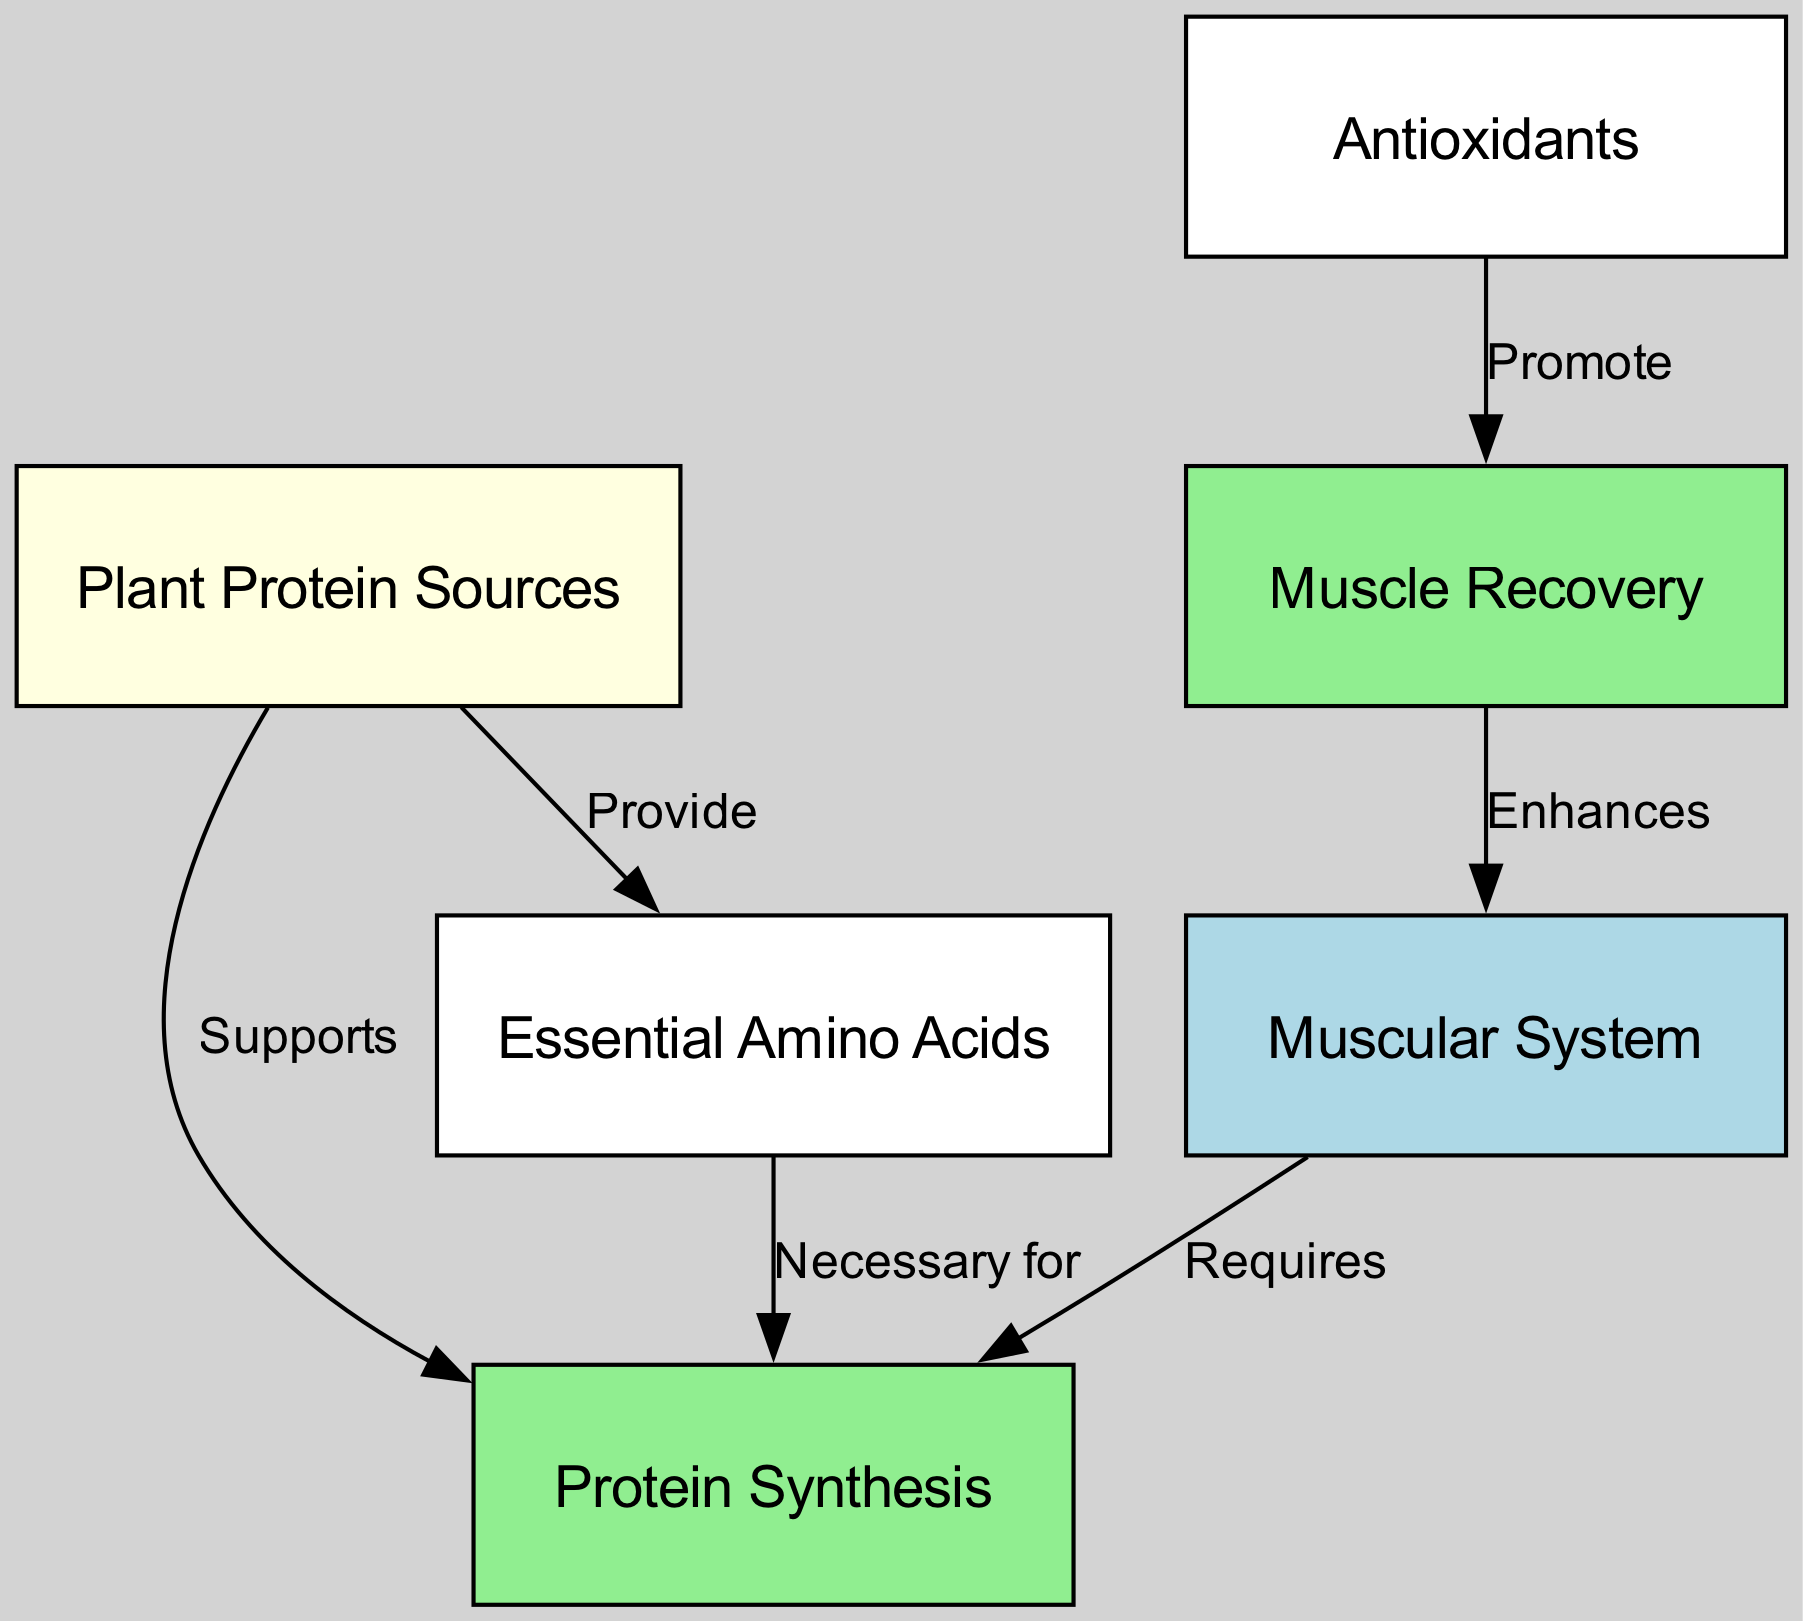What is required for the muscular system? The diagram shows that the muscular system requires protein synthesis, as indicated by the directed edge labeled "Requires" connecting these two nodes.
Answer: Protein Synthesis What enhances muscle recovery? The diagram indicates that muscle recovery is enhanced by the muscular system, as shown by the edge labeled "Enhances" leading back to the muscular system.
Answer: Muscular System How many nodes are present in the diagram? By counting the nodes listed, we see there are six distinct nodes in the diagram: muscular system, protein synthesis, plant protein sources, essential amino acids, muscle recovery, and antioxidants.
Answer: Six What promotes muscle recovery? The diagram specifies that antioxidants promote muscle recovery, indicated by the edge labeled "Promote" connecting antioxidants to muscle recovery.
Answer: Antioxidants What do plant protein sources provide? The diagram illustrates that plant protein sources provide essential amino acids, shown by the edge labeled "Provide" connecting these two nodes.
Answer: Essential Amino Acids Which node is colored light yellow? Observing the node colors, the plant protein sources node is highlighted in light yellow, distinguishing it from the others.
Answer: Plant Protein Sources What is necessary for protein synthesis? According to the diagram, essential amino acids are necessary for protein synthesis, as indicated by the edge labeled "Necessary for" connecting these two nodes.
Answer: Essential Amino Acids How do plant protein sources affect protein synthesis? The diagram shows that plant protein sources support protein synthesis, as indicated by the edge labeled "Supports" connecting these two nodes.
Answer: Supports 